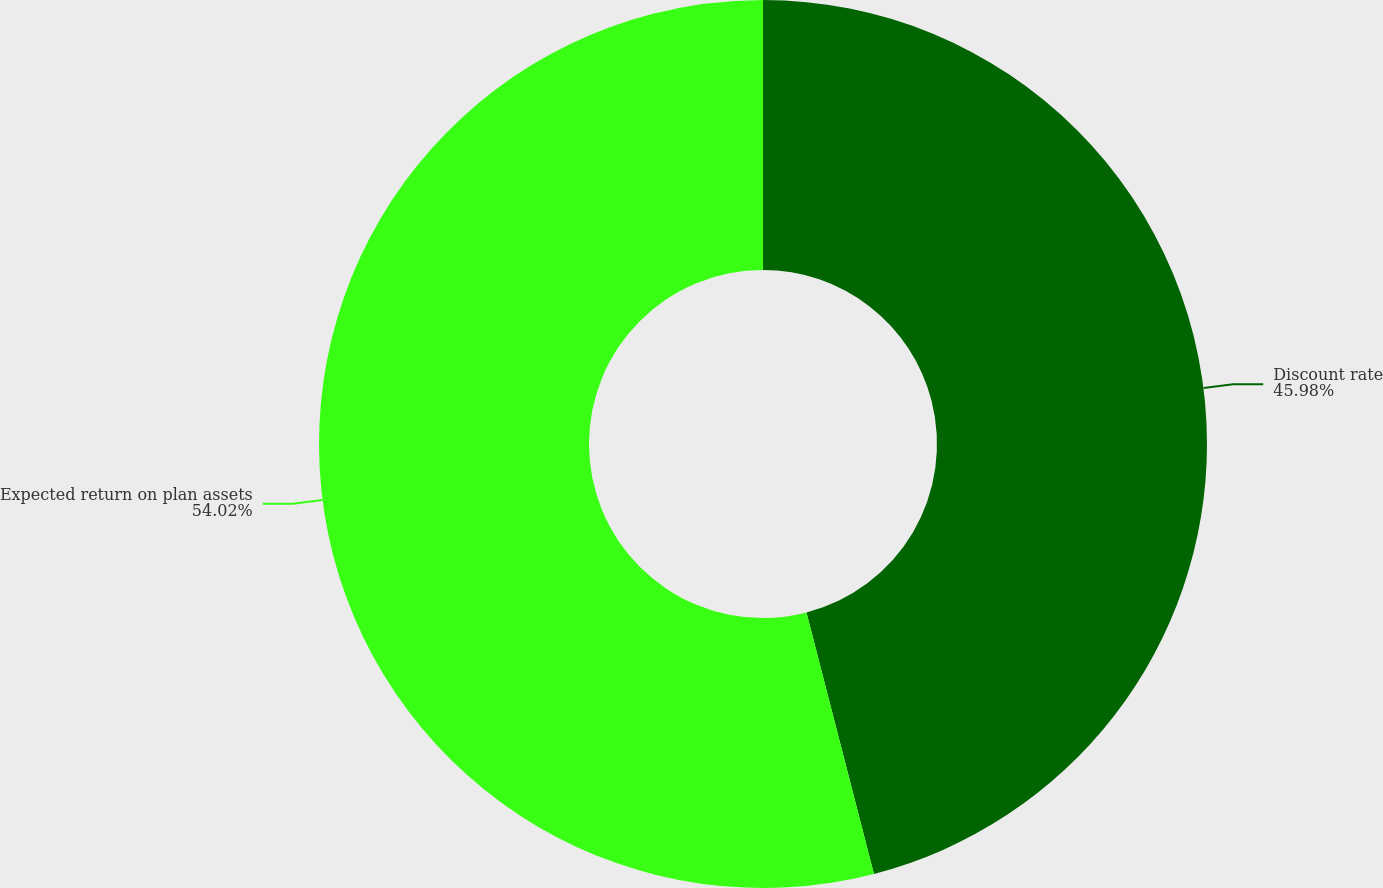Convert chart. <chart><loc_0><loc_0><loc_500><loc_500><pie_chart><fcel>Discount rate<fcel>Expected return on plan assets<nl><fcel>45.98%<fcel>54.02%<nl></chart> 